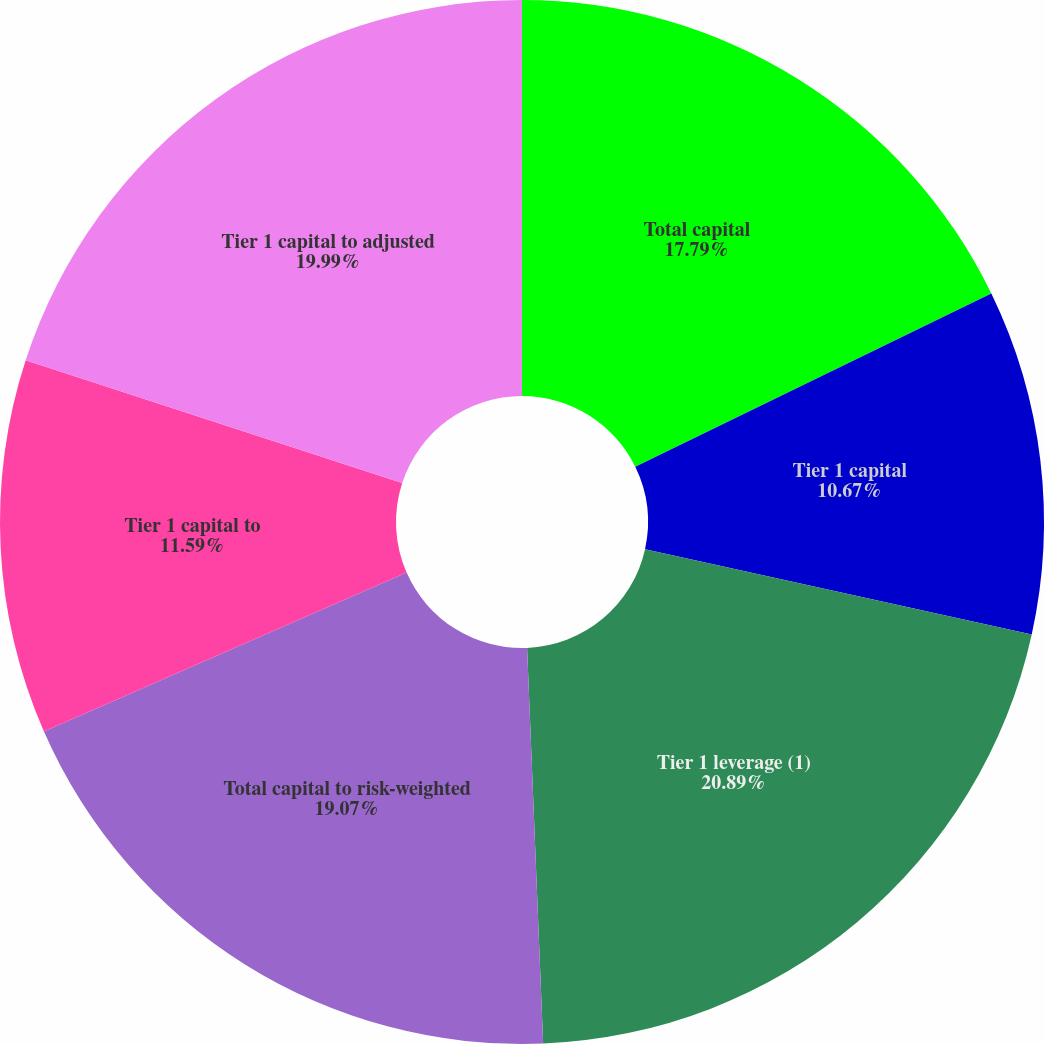<chart> <loc_0><loc_0><loc_500><loc_500><pie_chart><fcel>Total capital<fcel>Tier 1 capital<fcel>Tier 1 leverage (1)<fcel>Total capital to risk-weighted<fcel>Tier 1 capital to<fcel>Tier 1 capital to adjusted<nl><fcel>17.79%<fcel>10.67%<fcel>20.9%<fcel>19.07%<fcel>11.59%<fcel>19.99%<nl></chart> 